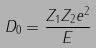<formula> <loc_0><loc_0><loc_500><loc_500>D _ { 0 } = \frac { Z _ { 1 } Z _ { 2 } e ^ { 2 } } { E }</formula> 